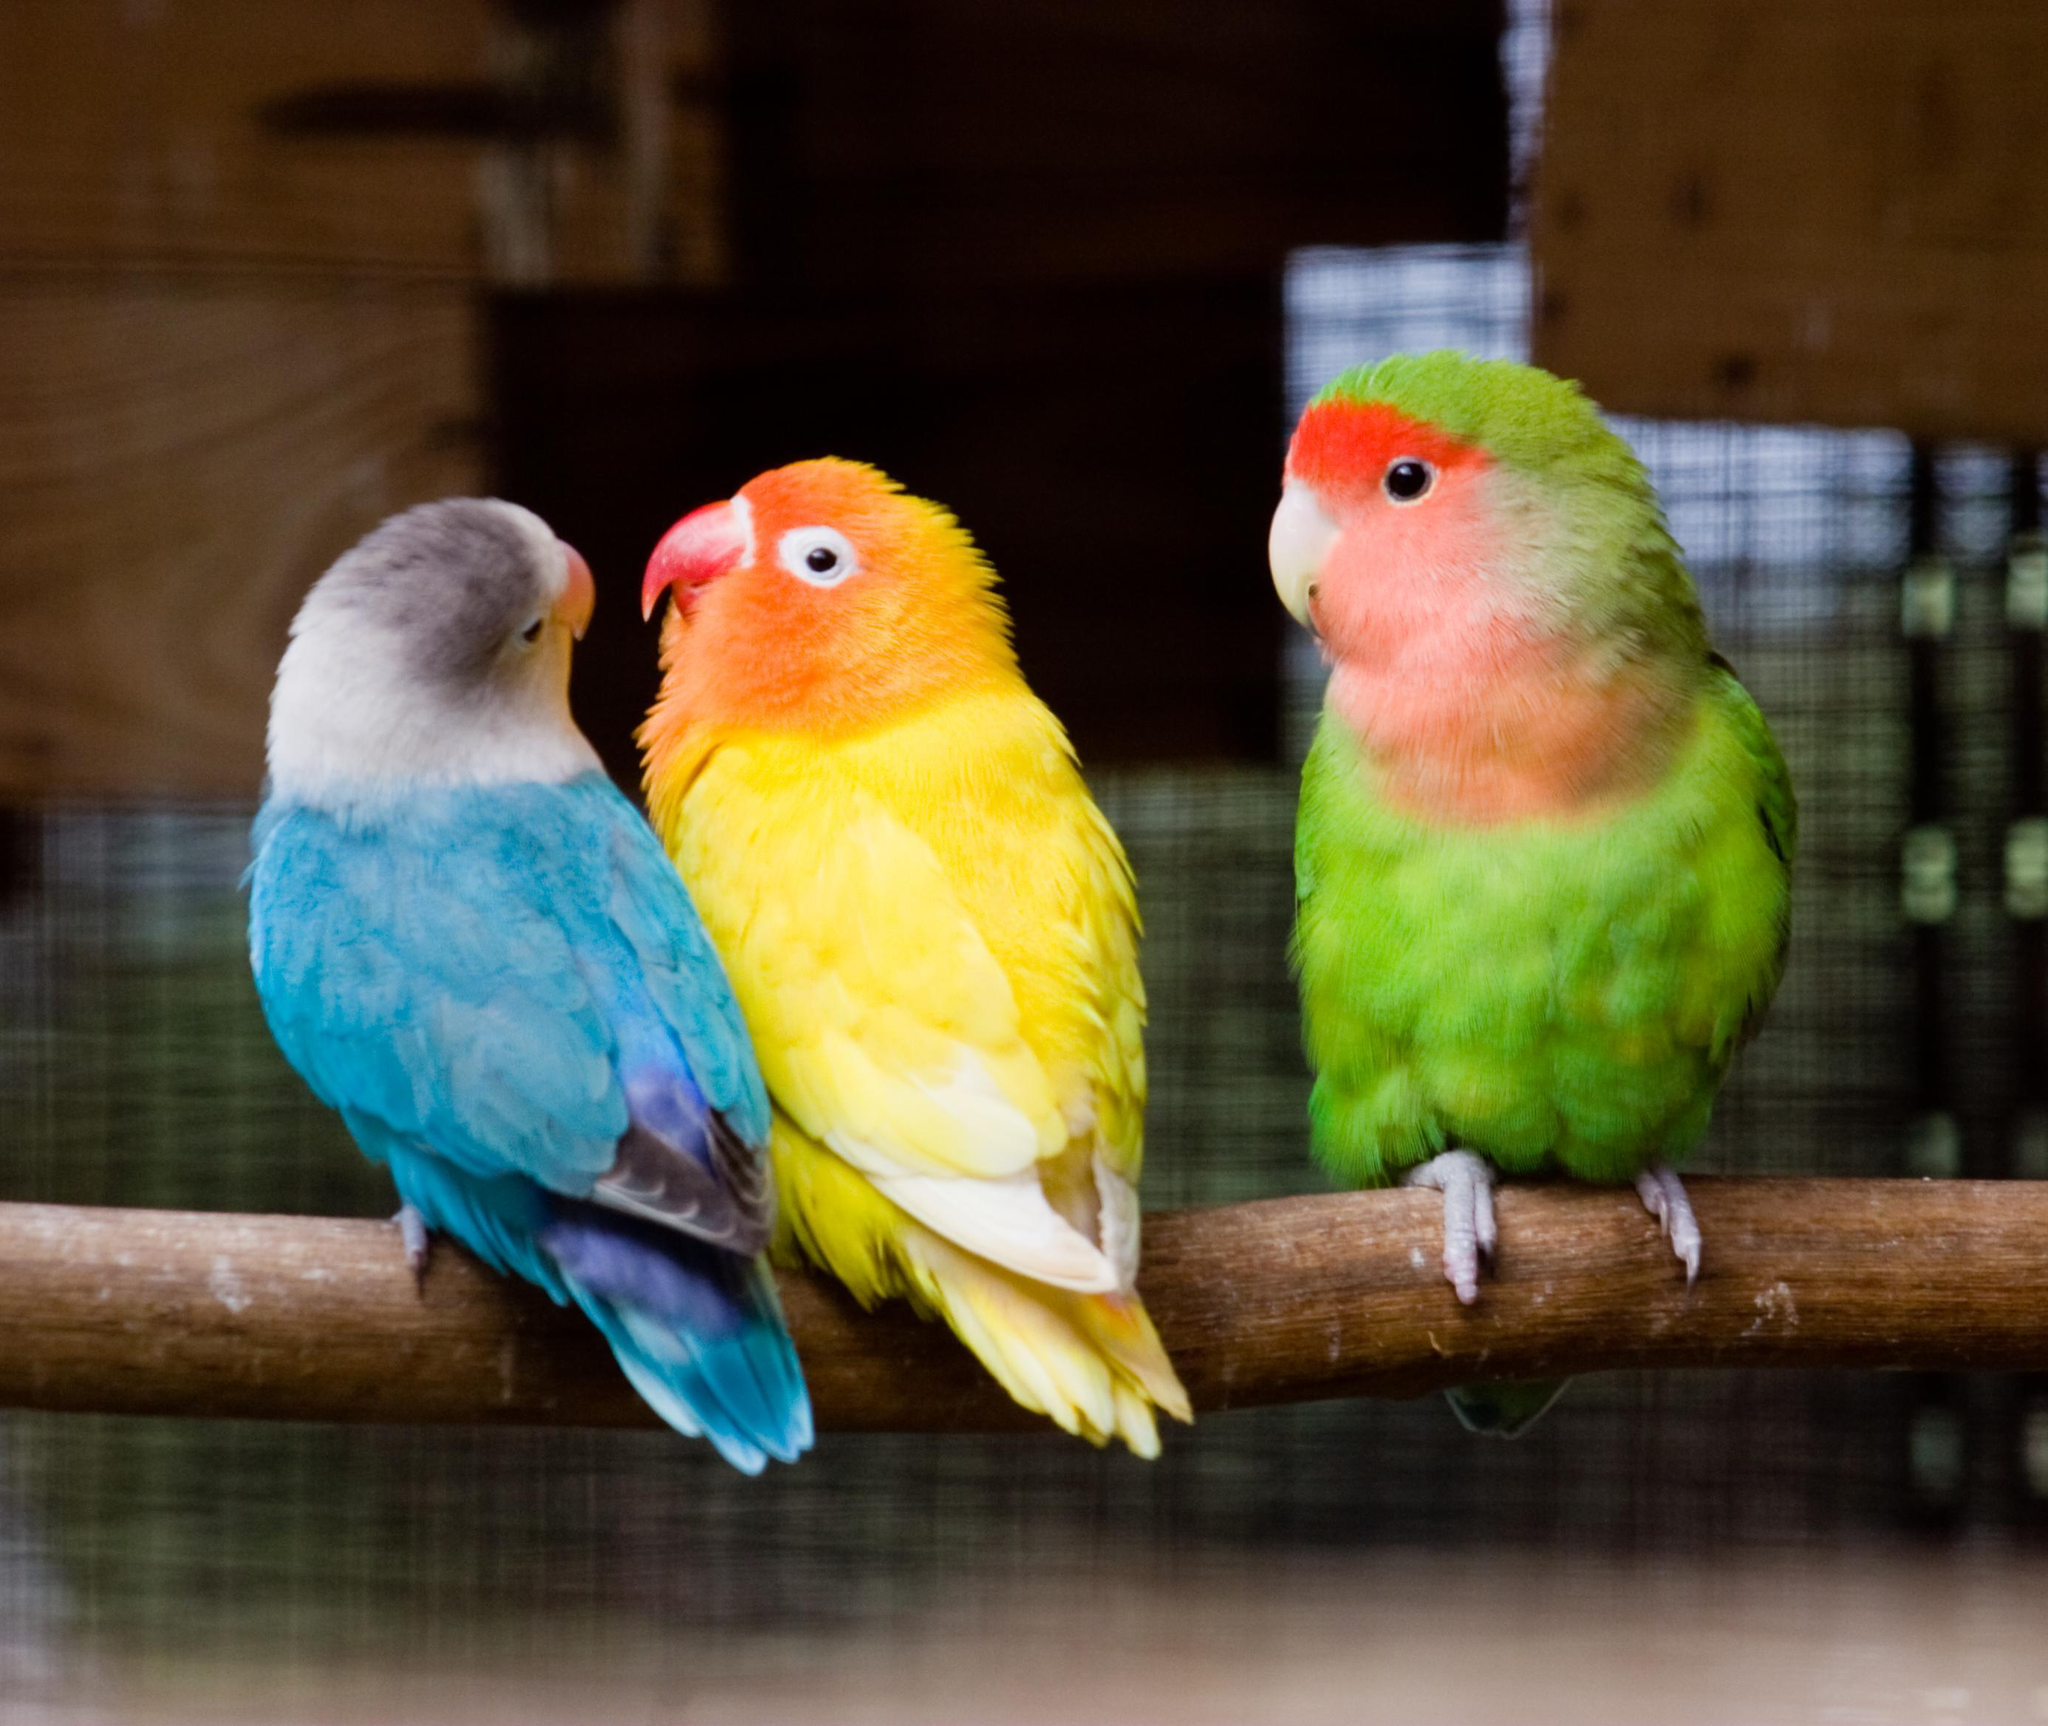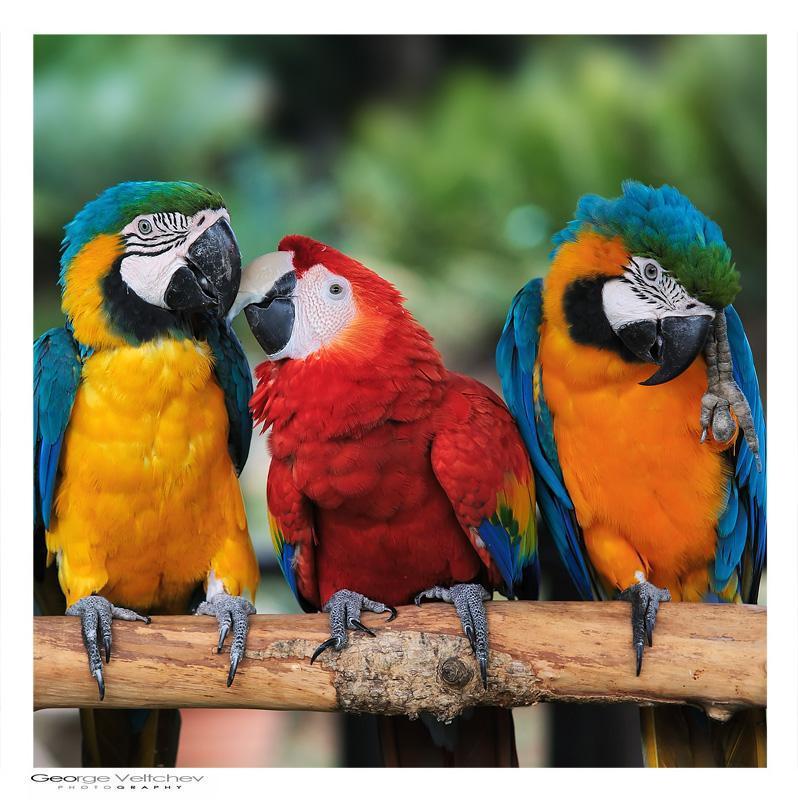The first image is the image on the left, the second image is the image on the right. Evaluate the accuracy of this statement regarding the images: "Each image shows a row of three birds perched on a branch, and no row of birds all share the same coloring.". Is it true? Answer yes or no. Yes. 